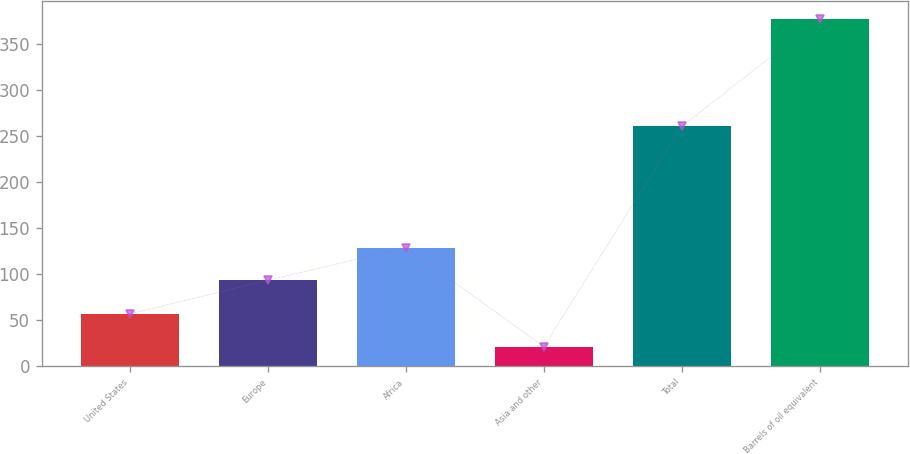<chart> <loc_0><loc_0><loc_500><loc_500><bar_chart><fcel>United States<fcel>Europe<fcel>Africa<fcel>Asia and other<fcel>Total<fcel>Barrels of oil equivalent<nl><fcel>56.6<fcel>93<fcel>128.6<fcel>21<fcel>260<fcel>377<nl></chart> 